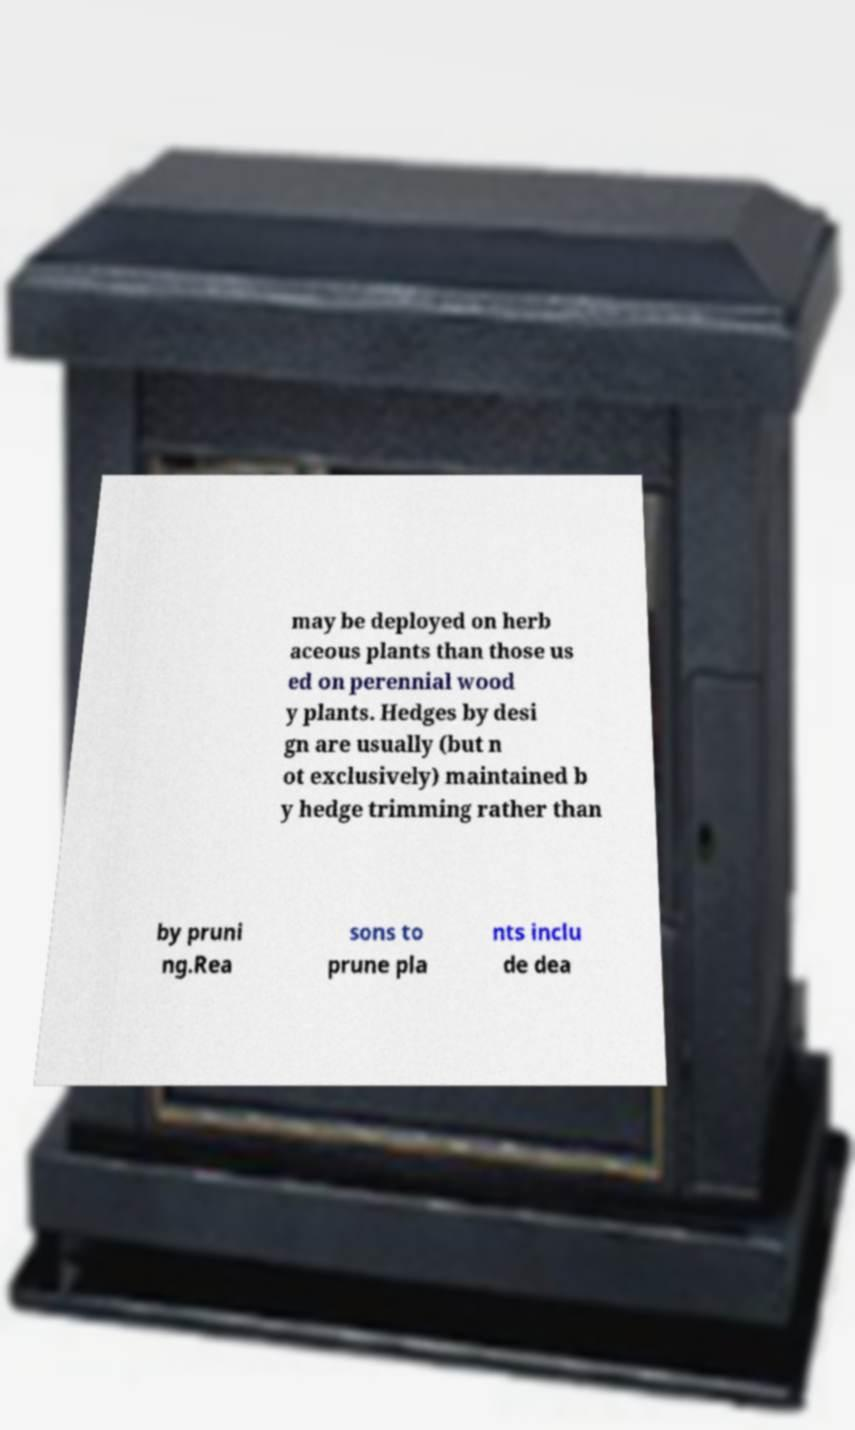There's text embedded in this image that I need extracted. Can you transcribe it verbatim? may be deployed on herb aceous plants than those us ed on perennial wood y plants. Hedges by desi gn are usually (but n ot exclusively) maintained b y hedge trimming rather than by pruni ng.Rea sons to prune pla nts inclu de dea 